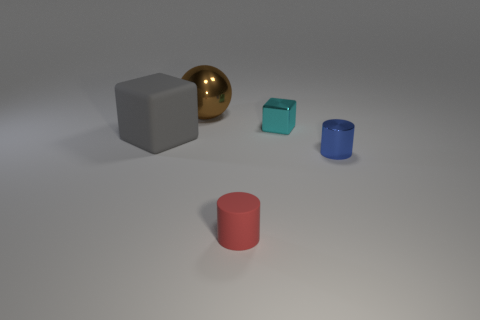Add 3 large gray rubber cubes. How many objects exist? 8 Subtract all red cylinders. How many cylinders are left? 1 Subtract all spheres. How many objects are left? 4 Subtract 2 cubes. How many cubes are left? 0 Subtract all gray cylinders. Subtract all blue blocks. How many cylinders are left? 2 Subtract all gray cubes. How many brown cylinders are left? 0 Subtract all tiny green matte spheres. Subtract all gray things. How many objects are left? 4 Add 4 matte objects. How many matte objects are left? 6 Add 1 tiny red cylinders. How many tiny red cylinders exist? 2 Subtract 0 red spheres. How many objects are left? 5 